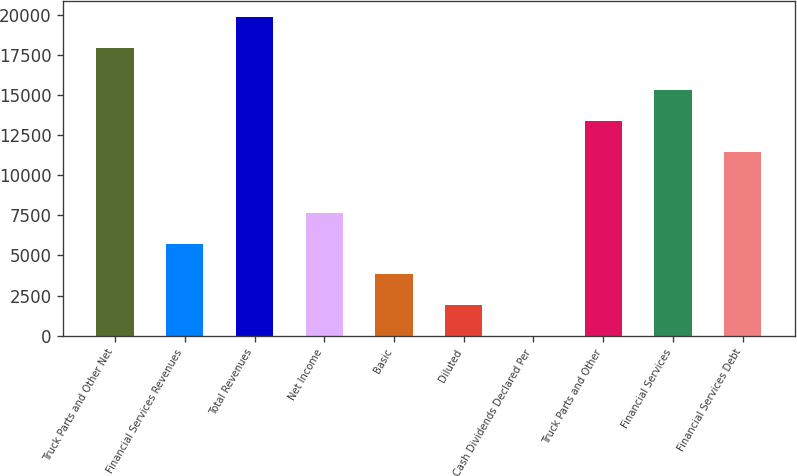Convert chart to OTSL. <chart><loc_0><loc_0><loc_500><loc_500><bar_chart><fcel>Truck Parts and Other Net<fcel>Financial Services Revenues<fcel>Total Revenues<fcel>Net Income<fcel>Basic<fcel>Diluted<fcel>Cash Dividends Declared Per<fcel>Truck Parts and Other<fcel>Financial Services<fcel>Financial Services Debt<nl><fcel>17942.8<fcel>5736.16<fcel>19854.1<fcel>7647.44<fcel>3824.88<fcel>1913.6<fcel>2.32<fcel>13381.3<fcel>15292.6<fcel>11470<nl></chart> 